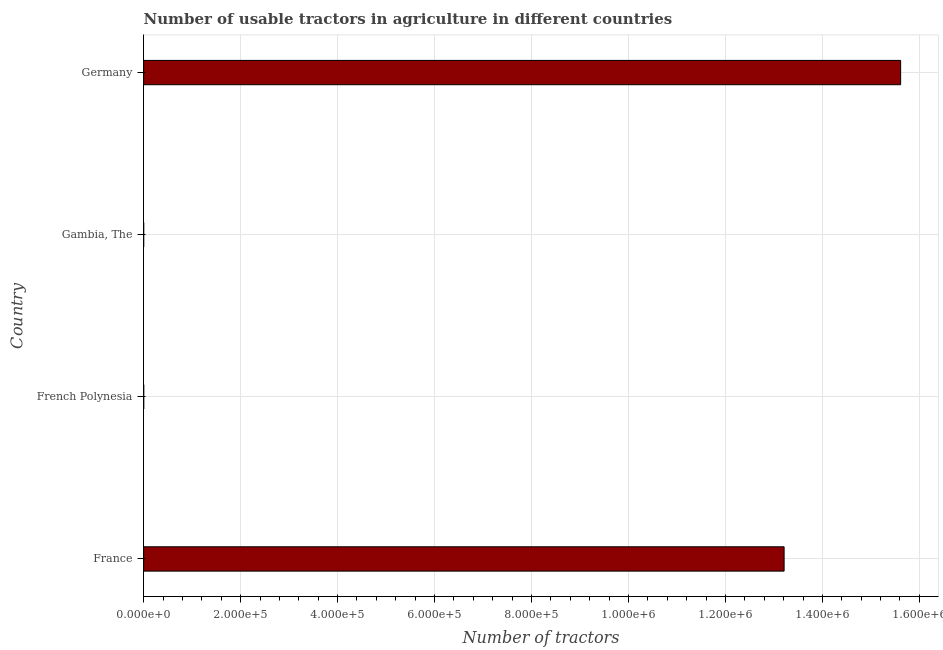Does the graph contain any zero values?
Keep it short and to the point. No. Does the graph contain grids?
Ensure brevity in your answer.  Yes. What is the title of the graph?
Provide a short and direct response. Number of usable tractors in agriculture in different countries. What is the label or title of the X-axis?
Make the answer very short. Number of tractors. What is the label or title of the Y-axis?
Offer a terse response. Country. What is the number of tractors in Germany?
Make the answer very short. 1.56e+06. Across all countries, what is the maximum number of tractors?
Your answer should be compact. 1.56e+06. In which country was the number of tractors minimum?
Your answer should be compact. Gambia, The. What is the sum of the number of tractors?
Give a very brief answer. 2.88e+06. What is the difference between the number of tractors in France and Germany?
Give a very brief answer. -2.40e+05. What is the average number of tractors per country?
Your answer should be very brief. 7.21e+05. What is the median number of tractors?
Give a very brief answer. 6.61e+05. In how many countries, is the number of tractors greater than 1160000 ?
Keep it short and to the point. 2. What is the ratio of the number of tractors in France to that in French Polynesia?
Ensure brevity in your answer.  9435.71. What is the difference between the highest and the second highest number of tractors?
Ensure brevity in your answer.  2.40e+05. Is the sum of the number of tractors in Gambia, The and Germany greater than the maximum number of tractors across all countries?
Offer a very short reply. Yes. What is the difference between the highest and the lowest number of tractors?
Your answer should be compact. 1.56e+06. In how many countries, is the number of tractors greater than the average number of tractors taken over all countries?
Give a very brief answer. 2. Are all the bars in the graph horizontal?
Ensure brevity in your answer.  Yes. Are the values on the major ticks of X-axis written in scientific E-notation?
Your response must be concise. Yes. What is the Number of tractors of France?
Your answer should be very brief. 1.32e+06. What is the Number of tractors in French Polynesia?
Ensure brevity in your answer.  140. What is the Number of tractors in Germany?
Provide a succinct answer. 1.56e+06. What is the difference between the Number of tractors in France and French Polynesia?
Provide a short and direct response. 1.32e+06. What is the difference between the Number of tractors in France and Gambia, The?
Your response must be concise. 1.32e+06. What is the difference between the Number of tractors in France and Germany?
Offer a very short reply. -2.40e+05. What is the difference between the Number of tractors in French Polynesia and Germany?
Make the answer very short. -1.56e+06. What is the difference between the Number of tractors in Gambia, The and Germany?
Your answer should be compact. -1.56e+06. What is the ratio of the Number of tractors in France to that in French Polynesia?
Offer a terse response. 9435.71. What is the ratio of the Number of tractors in France to that in Gambia, The?
Give a very brief answer. 2.94e+04. What is the ratio of the Number of tractors in France to that in Germany?
Your response must be concise. 0.85. What is the ratio of the Number of tractors in French Polynesia to that in Gambia, The?
Keep it short and to the point. 3.11. What is the ratio of the Number of tractors in French Polynesia to that in Germany?
Your answer should be compact. 0. What is the ratio of the Number of tractors in Gambia, The to that in Germany?
Make the answer very short. 0. 